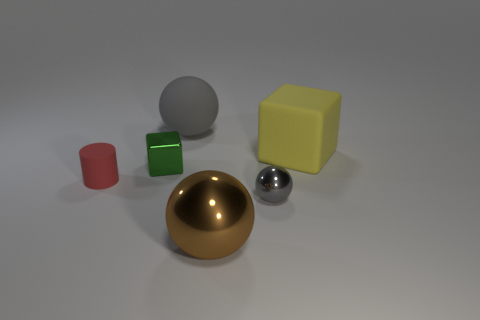How many big objects are in front of the big matte object right of the big object in front of the red cylinder?
Provide a short and direct response. 1. Do the large brown thing and the tiny red rubber object have the same shape?
Make the answer very short. No. Is the big ball in front of the gray metal sphere made of the same material as the cube in front of the yellow rubber block?
Your response must be concise. Yes. What number of objects are tiny objects that are left of the matte sphere or balls that are in front of the gray metallic object?
Offer a very short reply. 3. Are there any other things that are the same shape as the small green object?
Make the answer very short. Yes. What number of shiny objects are there?
Your answer should be compact. 3. Are there any purple metallic objects of the same size as the brown sphere?
Provide a short and direct response. No. Are the tiny green object and the large sphere that is right of the matte sphere made of the same material?
Provide a short and direct response. Yes. There is a large thing in front of the small matte cylinder; what is its material?
Provide a short and direct response. Metal. What size is the brown shiny ball?
Make the answer very short. Large. 